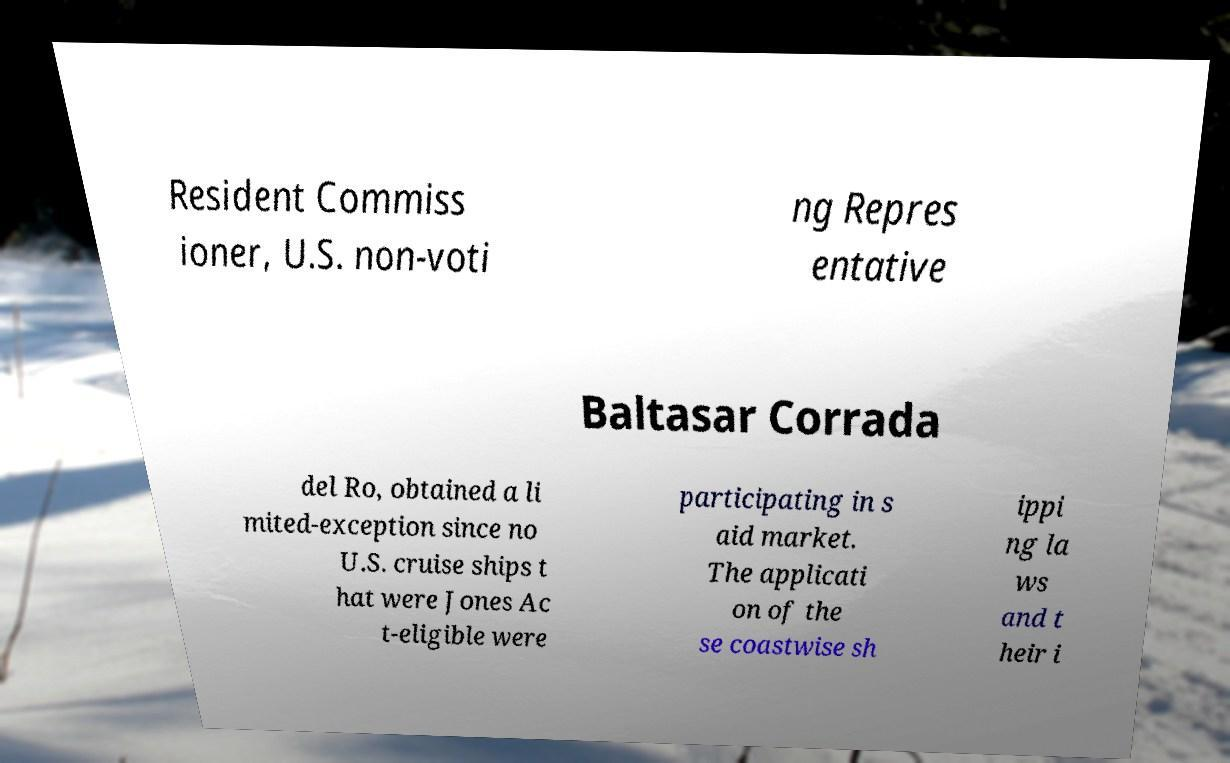For documentation purposes, I need the text within this image transcribed. Could you provide that? Resident Commiss ioner, U.S. non-voti ng Repres entative Baltasar Corrada del Ro, obtained a li mited-exception since no U.S. cruise ships t hat were Jones Ac t-eligible were participating in s aid market. The applicati on of the se coastwise sh ippi ng la ws and t heir i 